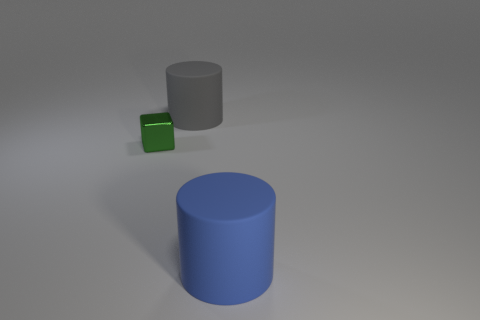Are there fewer tiny metal objects that are behind the small metallic object than matte balls?
Provide a short and direct response. No. What material is the tiny block?
Offer a terse response. Metal. What color is the tiny block?
Offer a very short reply. Green. There is a object that is on the left side of the blue rubber object and to the right of the tiny metal block; what is its color?
Offer a very short reply. Gray. Are there any other things that are made of the same material as the small thing?
Offer a very short reply. No. Are the blue cylinder and the large object that is behind the blue cylinder made of the same material?
Keep it short and to the point. Yes. How big is the cylinder that is behind the large matte cylinder that is in front of the tiny green block?
Offer a very short reply. Large. Is there anything else of the same color as the small block?
Offer a terse response. No. Do the cylinder that is right of the large gray cylinder and the object behind the tiny thing have the same material?
Offer a very short reply. Yes. There is a object that is both in front of the gray object and on the right side of the tiny object; what is it made of?
Make the answer very short. Rubber. 